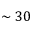Convert formula to latex. <formula><loc_0><loc_0><loc_500><loc_500>\sim 3 0</formula> 